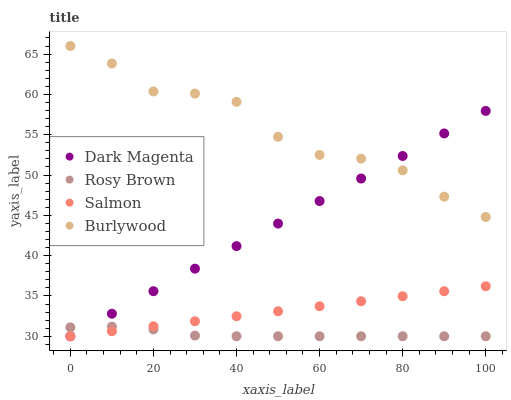Does Rosy Brown have the minimum area under the curve?
Answer yes or no. Yes. Does Burlywood have the maximum area under the curve?
Answer yes or no. Yes. Does Salmon have the minimum area under the curve?
Answer yes or no. No. Does Salmon have the maximum area under the curve?
Answer yes or no. No. Is Salmon the smoothest?
Answer yes or no. Yes. Is Burlywood the roughest?
Answer yes or no. Yes. Is Rosy Brown the smoothest?
Answer yes or no. No. Is Rosy Brown the roughest?
Answer yes or no. No. Does Rosy Brown have the lowest value?
Answer yes or no. Yes. Does Burlywood have the highest value?
Answer yes or no. Yes. Does Salmon have the highest value?
Answer yes or no. No. Is Rosy Brown less than Burlywood?
Answer yes or no. Yes. Is Burlywood greater than Salmon?
Answer yes or no. Yes. Does Rosy Brown intersect Salmon?
Answer yes or no. Yes. Is Rosy Brown less than Salmon?
Answer yes or no. No. Is Rosy Brown greater than Salmon?
Answer yes or no. No. Does Rosy Brown intersect Burlywood?
Answer yes or no. No. 